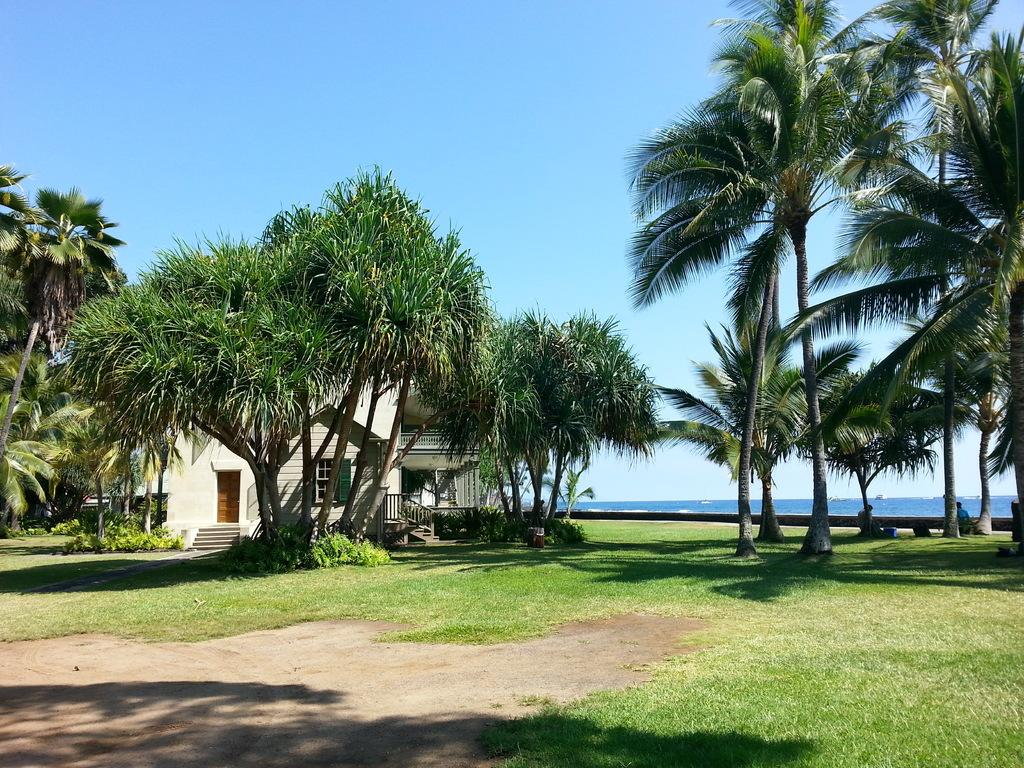What type of vegetation is present in the image? There are trees in the image. What is on the ground in the image? There is grass on the ground. What type of structure is in the image? There is a building in the image. What features can be seen on the building? The building has windows, railings, steps, and a door. What can be seen in the background of the image? Water and the sky are visible in the background. What type of pest can be seen crawling on the building in the image? There are no pests visible in the image; it only features trees, grass, a building, and the background elements. 